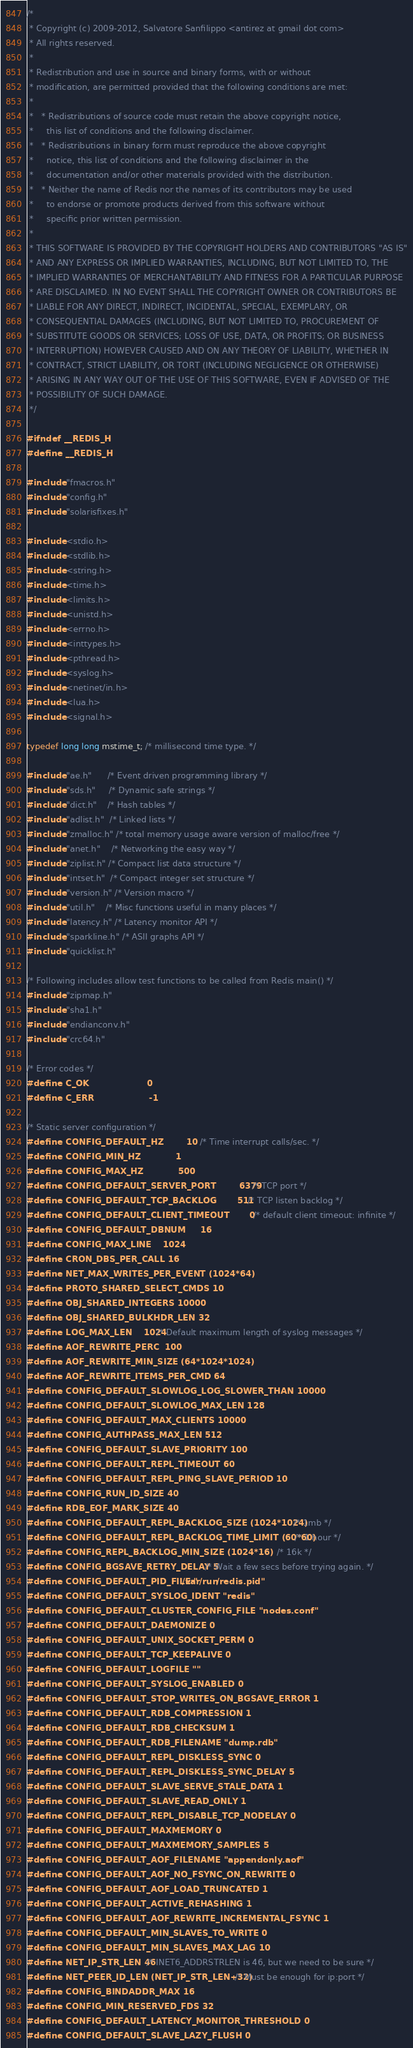<code> <loc_0><loc_0><loc_500><loc_500><_C_>/*
 * Copyright (c) 2009-2012, Salvatore Sanfilippo <antirez at gmail dot com>
 * All rights reserved.
 *
 * Redistribution and use in source and binary forms, with or without
 * modification, are permitted provided that the following conditions are met:
 *
 *   * Redistributions of source code must retain the above copyright notice,
 *     this list of conditions and the following disclaimer.
 *   * Redistributions in binary form must reproduce the above copyright
 *     notice, this list of conditions and the following disclaimer in the
 *     documentation and/or other materials provided with the distribution.
 *   * Neither the name of Redis nor the names of its contributors may be used
 *     to endorse or promote products derived from this software without
 *     specific prior written permission.
 *
 * THIS SOFTWARE IS PROVIDED BY THE COPYRIGHT HOLDERS AND CONTRIBUTORS "AS IS"
 * AND ANY EXPRESS OR IMPLIED WARRANTIES, INCLUDING, BUT NOT LIMITED TO, THE
 * IMPLIED WARRANTIES OF MERCHANTABILITY AND FITNESS FOR A PARTICULAR PURPOSE
 * ARE DISCLAIMED. IN NO EVENT SHALL THE COPYRIGHT OWNER OR CONTRIBUTORS BE
 * LIABLE FOR ANY DIRECT, INDIRECT, INCIDENTAL, SPECIAL, EXEMPLARY, OR
 * CONSEQUENTIAL DAMAGES (INCLUDING, BUT NOT LIMITED TO, PROCUREMENT OF
 * SUBSTITUTE GOODS OR SERVICES; LOSS OF USE, DATA, OR PROFITS; OR BUSINESS
 * INTERRUPTION) HOWEVER CAUSED AND ON ANY THEORY OF LIABILITY, WHETHER IN
 * CONTRACT, STRICT LIABILITY, OR TORT (INCLUDING NEGLIGENCE OR OTHERWISE)
 * ARISING IN ANY WAY OUT OF THE USE OF THIS SOFTWARE, EVEN IF ADVISED OF THE
 * POSSIBILITY OF SUCH DAMAGE.
 */

#ifndef __REDIS_H
#define __REDIS_H

#include "fmacros.h"
#include "config.h"
#include "solarisfixes.h"

#include <stdio.h>
#include <stdlib.h>
#include <string.h>
#include <time.h>
#include <limits.h>
#include <unistd.h>
#include <errno.h>
#include <inttypes.h>
#include <pthread.h>
#include <syslog.h>
#include <netinet/in.h>
#include <lua.h>
#include <signal.h>

typedef long long mstime_t; /* millisecond time type. */

#include "ae.h"      /* Event driven programming library */
#include "sds.h"     /* Dynamic safe strings */
#include "dict.h"    /* Hash tables */
#include "adlist.h"  /* Linked lists */
#include "zmalloc.h" /* total memory usage aware version of malloc/free */
#include "anet.h"    /* Networking the easy way */
#include "ziplist.h" /* Compact list data structure */
#include "intset.h"  /* Compact integer set structure */
#include "version.h" /* Version macro */
#include "util.h"    /* Misc functions useful in many places */
#include "latency.h" /* Latency monitor API */
#include "sparkline.h" /* ASII graphs API */
#include "quicklist.h"

/* Following includes allow test functions to be called from Redis main() */
#include "zipmap.h"
#include "sha1.h"
#include "endianconv.h"
#include "crc64.h"

/* Error codes */
#define C_OK                    0
#define C_ERR                   -1

/* Static server configuration */
#define CONFIG_DEFAULT_HZ        10      /* Time interrupt calls/sec. */
#define CONFIG_MIN_HZ            1
#define CONFIG_MAX_HZ            500
#define CONFIG_DEFAULT_SERVER_PORT        6379    /* TCP port */
#define CONFIG_DEFAULT_TCP_BACKLOG       511     /* TCP listen backlog */
#define CONFIG_DEFAULT_CLIENT_TIMEOUT       0       /* default client timeout: infinite */
#define CONFIG_DEFAULT_DBNUM     16
#define CONFIG_MAX_LINE    1024
#define CRON_DBS_PER_CALL 16
#define NET_MAX_WRITES_PER_EVENT (1024*64)
#define PROTO_SHARED_SELECT_CMDS 10
#define OBJ_SHARED_INTEGERS 10000
#define OBJ_SHARED_BULKHDR_LEN 32
#define LOG_MAX_LEN    1024 /* Default maximum length of syslog messages */
#define AOF_REWRITE_PERC  100
#define AOF_REWRITE_MIN_SIZE (64*1024*1024)
#define AOF_REWRITE_ITEMS_PER_CMD 64
#define CONFIG_DEFAULT_SLOWLOG_LOG_SLOWER_THAN 10000
#define CONFIG_DEFAULT_SLOWLOG_MAX_LEN 128
#define CONFIG_DEFAULT_MAX_CLIENTS 10000
#define CONFIG_AUTHPASS_MAX_LEN 512
#define CONFIG_DEFAULT_SLAVE_PRIORITY 100
#define CONFIG_DEFAULT_REPL_TIMEOUT 60
#define CONFIG_DEFAULT_REPL_PING_SLAVE_PERIOD 10
#define CONFIG_RUN_ID_SIZE 40
#define RDB_EOF_MARK_SIZE 40
#define CONFIG_DEFAULT_REPL_BACKLOG_SIZE (1024*1024)    /* 1mb */
#define CONFIG_DEFAULT_REPL_BACKLOG_TIME_LIMIT (60*60)  /* 1 hour */
#define CONFIG_REPL_BACKLOG_MIN_SIZE (1024*16)          /* 16k */
#define CONFIG_BGSAVE_RETRY_DELAY 5 /* Wait a few secs before trying again. */
#define CONFIG_DEFAULT_PID_FILE "/var/run/redis.pid"
#define CONFIG_DEFAULT_SYSLOG_IDENT "redis"
#define CONFIG_DEFAULT_CLUSTER_CONFIG_FILE "nodes.conf"
#define CONFIG_DEFAULT_DAEMONIZE 0
#define CONFIG_DEFAULT_UNIX_SOCKET_PERM 0
#define CONFIG_DEFAULT_TCP_KEEPALIVE 0
#define CONFIG_DEFAULT_LOGFILE ""
#define CONFIG_DEFAULT_SYSLOG_ENABLED 0
#define CONFIG_DEFAULT_STOP_WRITES_ON_BGSAVE_ERROR 1
#define CONFIG_DEFAULT_RDB_COMPRESSION 1
#define CONFIG_DEFAULT_RDB_CHECKSUM 1
#define CONFIG_DEFAULT_RDB_FILENAME "dump.rdb"
#define CONFIG_DEFAULT_REPL_DISKLESS_SYNC 0
#define CONFIG_DEFAULT_REPL_DISKLESS_SYNC_DELAY 5
#define CONFIG_DEFAULT_SLAVE_SERVE_STALE_DATA 1
#define CONFIG_DEFAULT_SLAVE_READ_ONLY 1
#define CONFIG_DEFAULT_REPL_DISABLE_TCP_NODELAY 0
#define CONFIG_DEFAULT_MAXMEMORY 0
#define CONFIG_DEFAULT_MAXMEMORY_SAMPLES 5
#define CONFIG_DEFAULT_AOF_FILENAME "appendonly.aof"
#define CONFIG_DEFAULT_AOF_NO_FSYNC_ON_REWRITE 0
#define CONFIG_DEFAULT_AOF_LOAD_TRUNCATED 1
#define CONFIG_DEFAULT_ACTIVE_REHASHING 1
#define CONFIG_DEFAULT_AOF_REWRITE_INCREMENTAL_FSYNC 1
#define CONFIG_DEFAULT_MIN_SLAVES_TO_WRITE 0
#define CONFIG_DEFAULT_MIN_SLAVES_MAX_LAG 10
#define NET_IP_STR_LEN 46 /* INET6_ADDRSTRLEN is 46, but we need to be sure */
#define NET_PEER_ID_LEN (NET_IP_STR_LEN+32) /* Must be enough for ip:port */
#define CONFIG_BINDADDR_MAX 16
#define CONFIG_MIN_RESERVED_FDS 32
#define CONFIG_DEFAULT_LATENCY_MONITOR_THRESHOLD 0
#define CONFIG_DEFAULT_SLAVE_LAZY_FLUSH 0</code> 